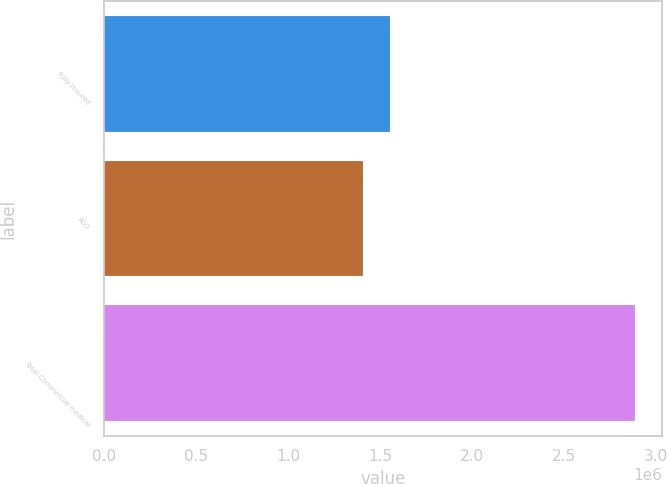<chart> <loc_0><loc_0><loc_500><loc_500><bar_chart><fcel>Fully-insured<fcel>ASO<fcel>Total Commercial medical<nl><fcel>1.55427e+06<fcel>1.4062e+06<fcel>2.8869e+06<nl></chart> 